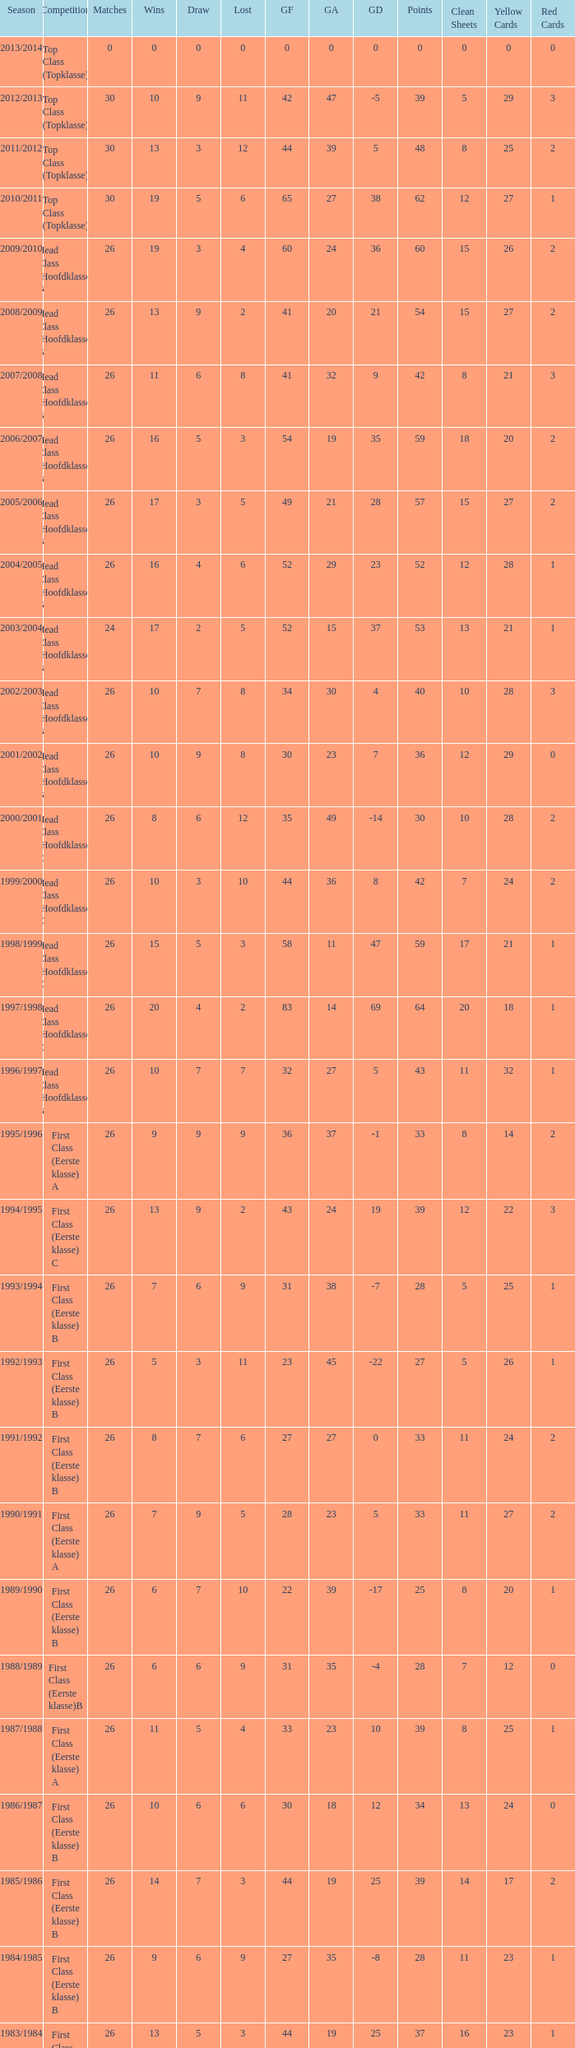In which competitive event is a score over 30, a stalemate under 5, and a failure more than 10? Top Class (Topklasse). 